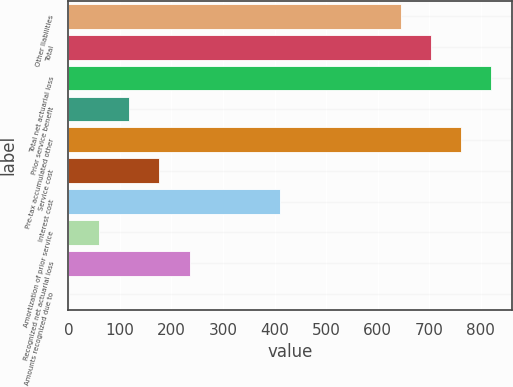Convert chart. <chart><loc_0><loc_0><loc_500><loc_500><bar_chart><fcel>Other liabilities<fcel>Total<fcel>Total net actuarial loss<fcel>Prior service benefit<fcel>Pre-tax accumulated other<fcel>Service cost<fcel>Interest cost<fcel>Amortization of prior service<fcel>Recognized net actuarial loss<fcel>Amounts recognized due to<nl><fcel>644.84<fcel>703.38<fcel>820.46<fcel>117.98<fcel>761.92<fcel>176.52<fcel>410.68<fcel>59.44<fcel>235.06<fcel>0.9<nl></chart> 